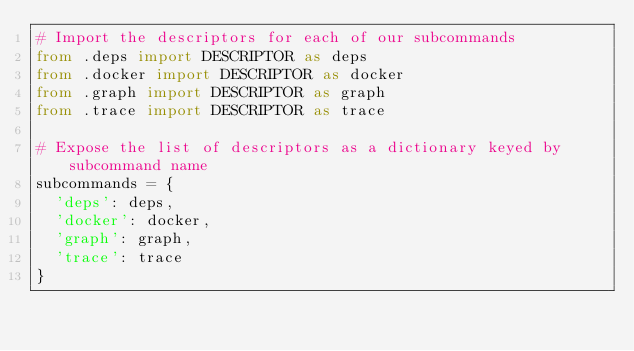Convert code to text. <code><loc_0><loc_0><loc_500><loc_500><_Python_># Import the descriptors for each of our subcommands
from .deps import DESCRIPTOR as deps
from .docker import DESCRIPTOR as docker
from .graph import DESCRIPTOR as graph
from .trace import DESCRIPTOR as trace

# Expose the list of descriptors as a dictionary keyed by subcommand name
subcommands = {
	'deps': deps,
	'docker': docker,
	'graph': graph,
	'trace': trace
}
</code> 